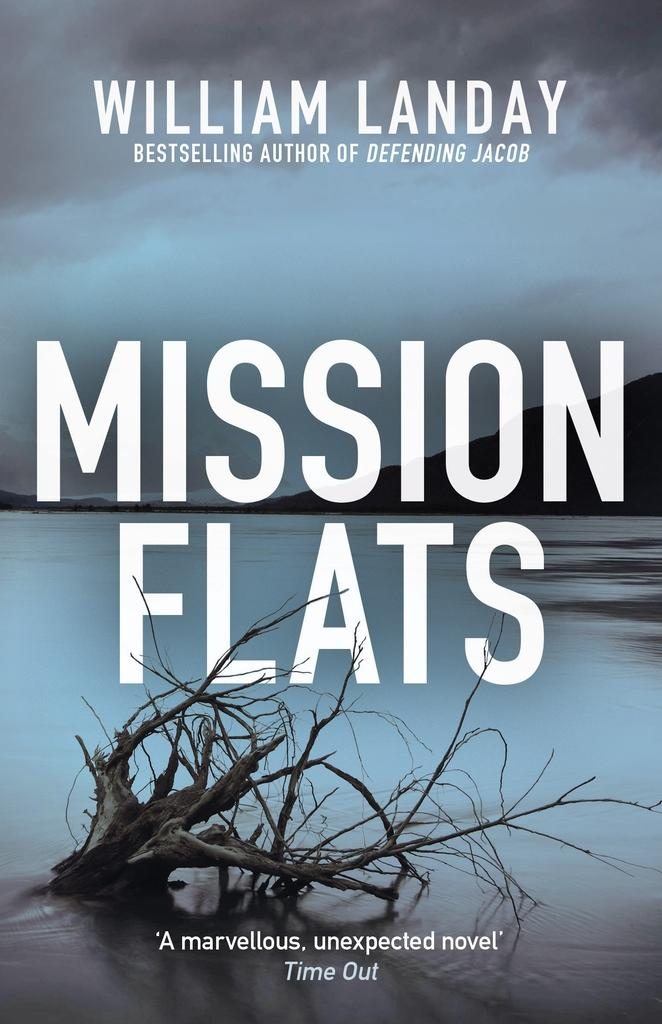<image>
Create a compact narrative representing the image presented. a book that is titled mission flats by william landay 